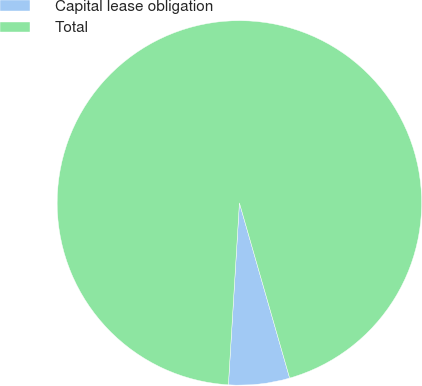Convert chart. <chart><loc_0><loc_0><loc_500><loc_500><pie_chart><fcel>Capital lease obligation<fcel>Total<nl><fcel>5.41%<fcel>94.59%<nl></chart> 